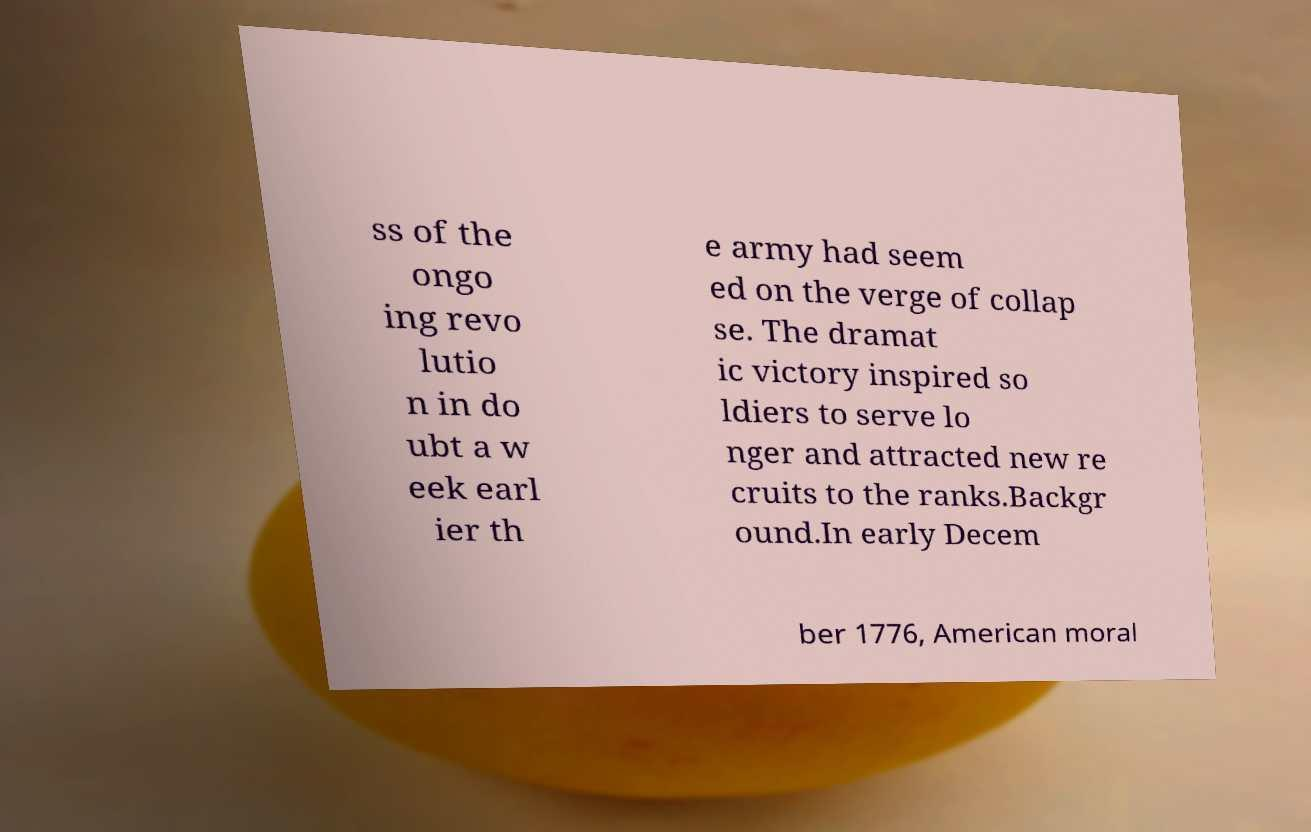Can you read and provide the text displayed in the image?This photo seems to have some interesting text. Can you extract and type it out for me? ss of the ongo ing revo lutio n in do ubt a w eek earl ier th e army had seem ed on the verge of collap se. The dramat ic victory inspired so ldiers to serve lo nger and attracted new re cruits to the ranks.Backgr ound.In early Decem ber 1776, American moral 